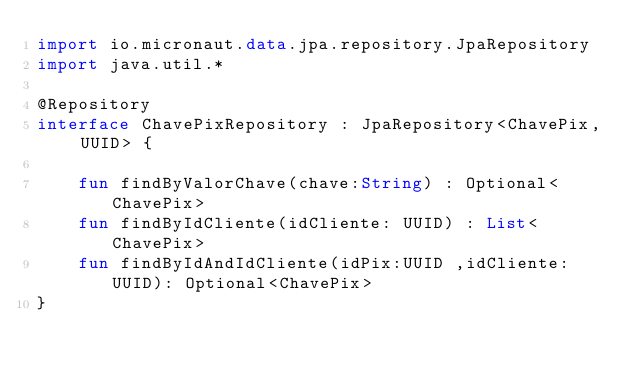Convert code to text. <code><loc_0><loc_0><loc_500><loc_500><_Kotlin_>import io.micronaut.data.jpa.repository.JpaRepository
import java.util.*

@Repository
interface ChavePixRepository : JpaRepository<ChavePix, UUID> {

    fun findByValorChave(chave:String) : Optional<ChavePix>
    fun findByIdCliente(idCliente: UUID) : List<ChavePix>
    fun findByIdAndIdCliente(idPix:UUID ,idCliente: UUID): Optional<ChavePix>
}</code> 